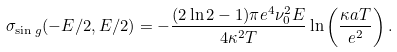<formula> <loc_0><loc_0><loc_500><loc_500>\sigma _ { \sin g } ( - E / 2 , E / 2 ) = - \frac { ( 2 \ln 2 - 1 ) \pi e ^ { 4 } \nu _ { 0 } ^ { 2 } E } { 4 \kappa ^ { 2 } T } \ln \left ( \frac { \kappa a T } { e ^ { 2 } } \right ) .</formula> 